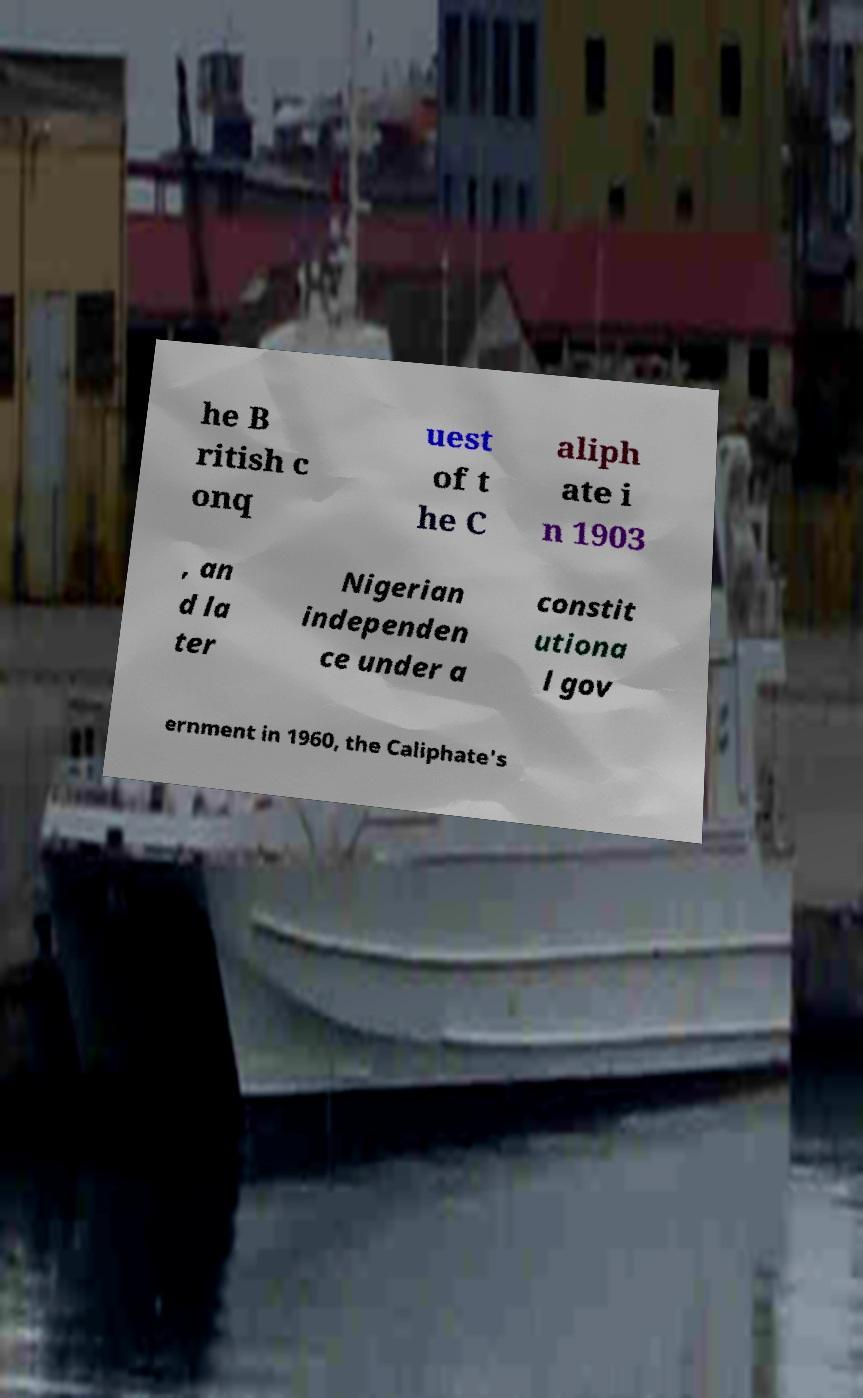Please read and relay the text visible in this image. What does it say? he B ritish c onq uest of t he C aliph ate i n 1903 , an d la ter Nigerian independen ce under a constit utiona l gov ernment in 1960, the Caliphate's 